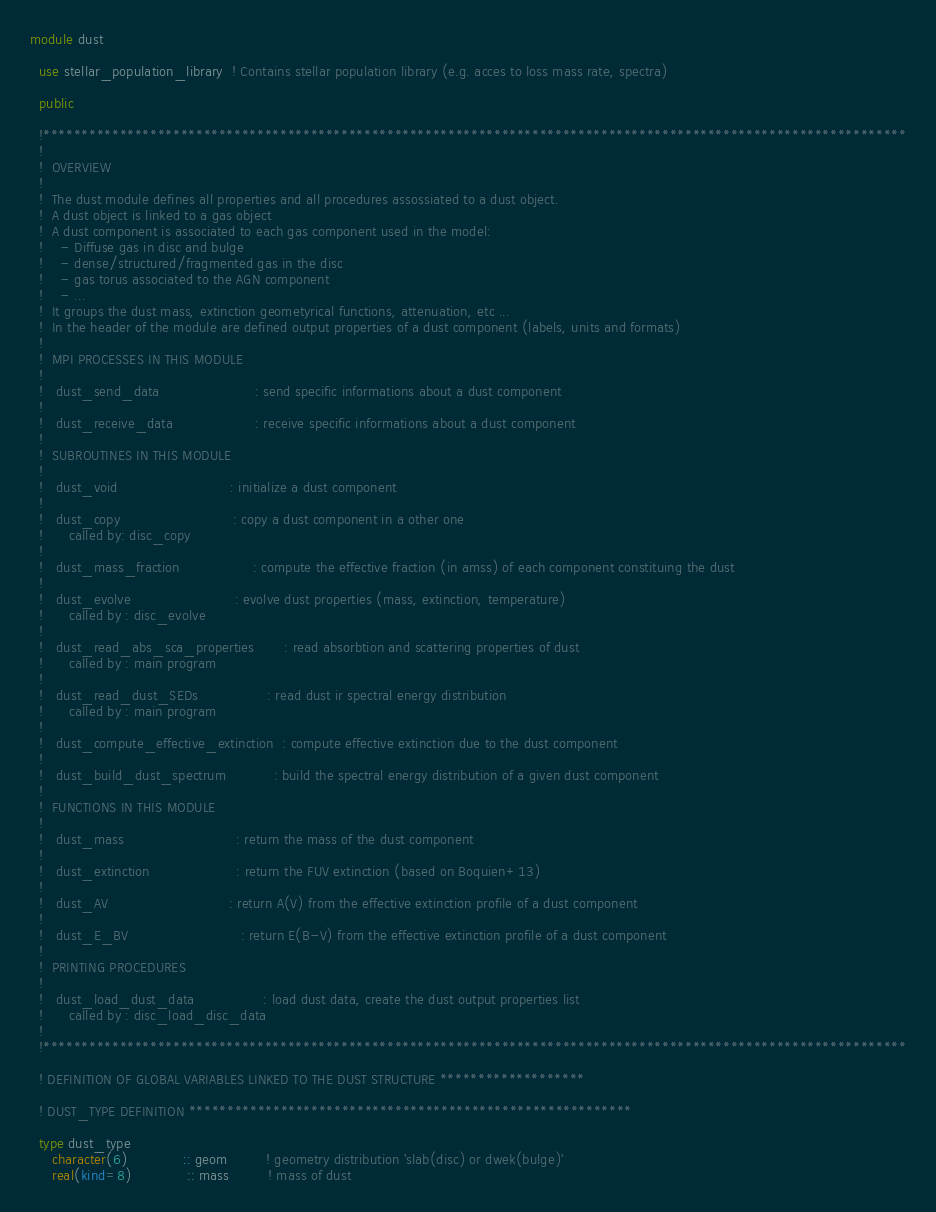Convert code to text. <code><loc_0><loc_0><loc_500><loc_500><_FORTRAN_>module dust

  use stellar_population_library  ! Contains stellar population library (e.g. acces to loss mass rate, spectra)

  public
  
  !*****************************************************************************************************************
  ! 
  !  OVERVIEW
  ! 
  !  The dust module defines all properties and all procedures assossiated to a dust object. 
  !  A dust object is linked to a gas object
  !  A dust component is associated to each gas component used in the model: 
  !    - Diffuse gas in disc and bulge
  !    - dense/structured/fragmented gas in the disc
  !    - gas torus associated to the AGN component
  !    - ...
  !  It groups the dust mass, extinction geometyrical functions, attenuation, etc ...
  !  In the header of the module are defined output properties of a dust component (labels, units and formats)
  !
  !  MPI PROCESSES IN THIS MODULE
  !
  !   dust_send_data                      : send specific informations about a dust component
  !
  !   dust_receive_data                   : receive specific informations about a dust component
  !
  !  SUBROUTINES IN THIS MODULE
  !
  !   dust_void                          : initialize a dust component
  !
  !   dust_copy                          : copy a dust component in a other one
  !      called by: disc_copy
  !
  !   dust_mass_fraction                 : compute the effective fraction (in amss) of each component constituing the dust
  !
  !   dust_evolve                        : evolve dust properties (mass, extinction, temperature)
  !      called by : disc_evolve
  !
  !   dust_read_abs_sca_properties       : read absorbtion and scattering properties of dust 
  !      called by : main program 
  !
  !   dust_read_dust_SEDs                : read dust ir spectral energy distribution
  !      called by : main program 
  !
  !   dust_compute_effective_extinction  : compute effective extinction due to the dust component
  !
  !   dust_build_dust_spectrum           : build the spectral energy distribution of a given dust component
  !
  !  FUNCTIONS IN THIS MODULE
  !
  !   dust_mass                          : return the mass of the dust component
  !
  !   dust_extinction                    : return the FUV extinction (based on Boquien+13)  
  !
  !   dust_AV                            : return A(V) from the effective extinction profile of a dust component
  !
  !   dust_E_BV                          : return E(B-V) from the effective extinction profile of a dust component
  !
  !  PRINTING PROCEDURES
  !
  !   dust_load_dust_data                : load dust data, create the dust output properties list 
  !      called by : disc_load_disc_data
  !
  !*****************************************************************************************************************

  ! DEFINITION OF GLOBAL VARIABLES LINKED TO THE DUST STRUCTURE *******************

  ! DUST_TYPE DEFINITION **********************************************************

  type dust_type
     character(6)             :: geom         ! geometry distribution 'slab(disc) or dwek(bulge)'
     real(kind=8)             :: mass         ! mass of dust</code> 